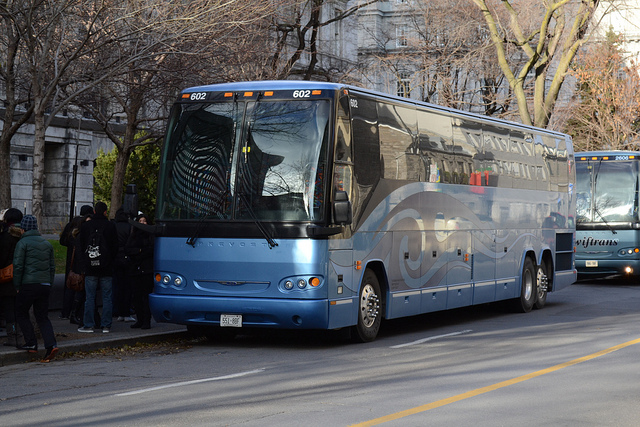What is the destination of the bus? The destination sign on the front of the bus isn't legible in the photo, so it's not possible to accurately determine the bus's destination. However, based on its design, it looks like a charter or tour bus, which could be taking passengers to a variety of locations, such as cities, tourist attractions, or events. 